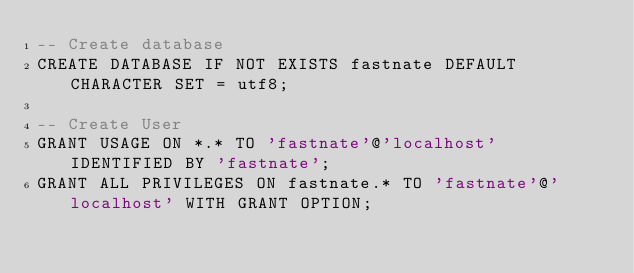<code> <loc_0><loc_0><loc_500><loc_500><_SQL_>-- Create database
CREATE DATABASE IF NOT EXISTS fastnate DEFAULT CHARACTER SET = utf8;

-- Create User 
GRANT USAGE ON *.* TO 'fastnate'@'localhost' IDENTIFIED BY 'fastnate';
GRANT ALL PRIVILEGES ON fastnate.* TO 'fastnate'@'localhost' WITH GRANT OPTION;
</code> 